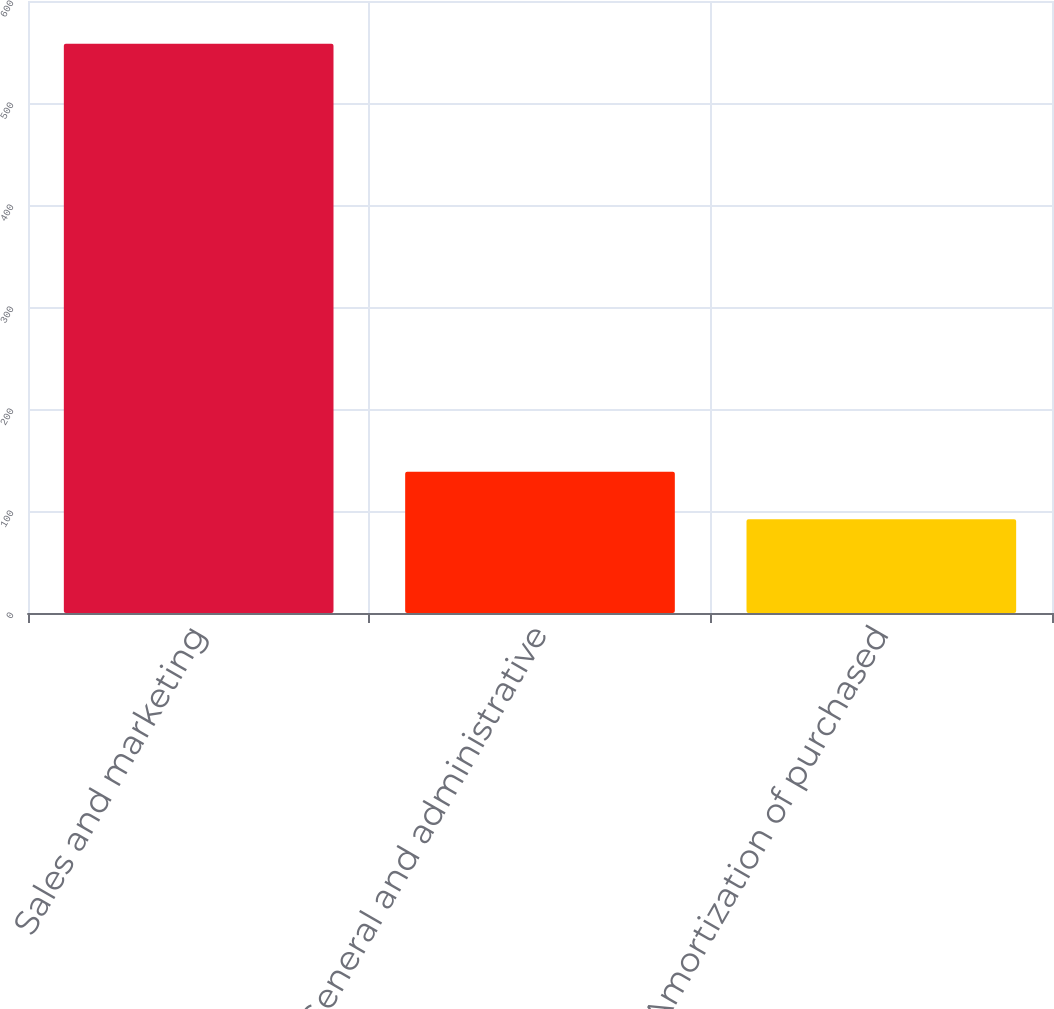<chart> <loc_0><loc_0><loc_500><loc_500><bar_chart><fcel>Sales and marketing<fcel>General and administrative<fcel>Amortization of purchased<nl><fcel>558<fcel>138.42<fcel>91.8<nl></chart> 